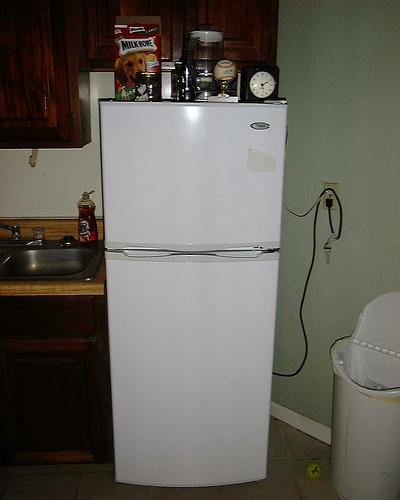What brand is this fridge?
Write a very short answer. Frigidaire. What is the small red canister on the wall?
Give a very brief answer. Dish soap. What is the dog treat that is visible?
Short answer required. Milk bone. What are all the wires for?
Answer briefly. Refrigerator. Is the sink full of water?
Be succinct. No. Is it daytime?
Give a very brief answer. Yes. What is the appliance in the middle of the room called?
Keep it brief. Fridge. What color is the fridge?
Write a very short answer. White. What is on top of the fridge?
Quick response, please. Food. What kind of appliance is this?
Answer briefly. Refrigerator. 